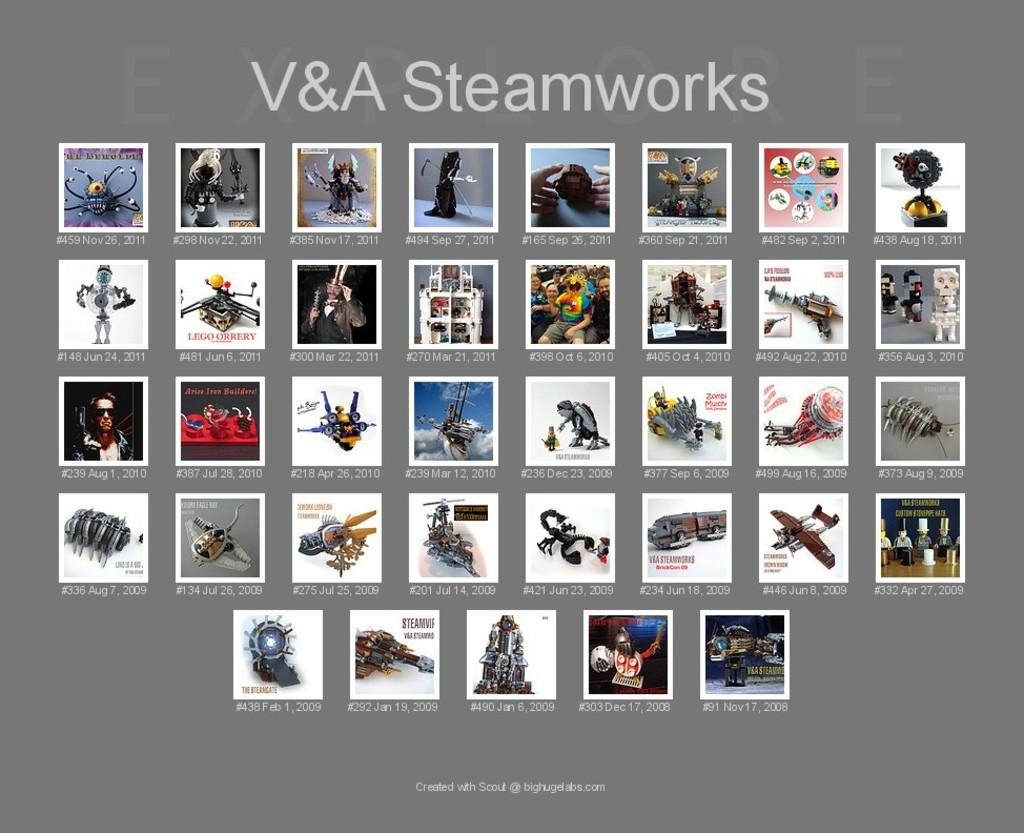<image>
Write a terse but informative summary of the picture. A series of small photographs with the words V&A Steamworks above them 